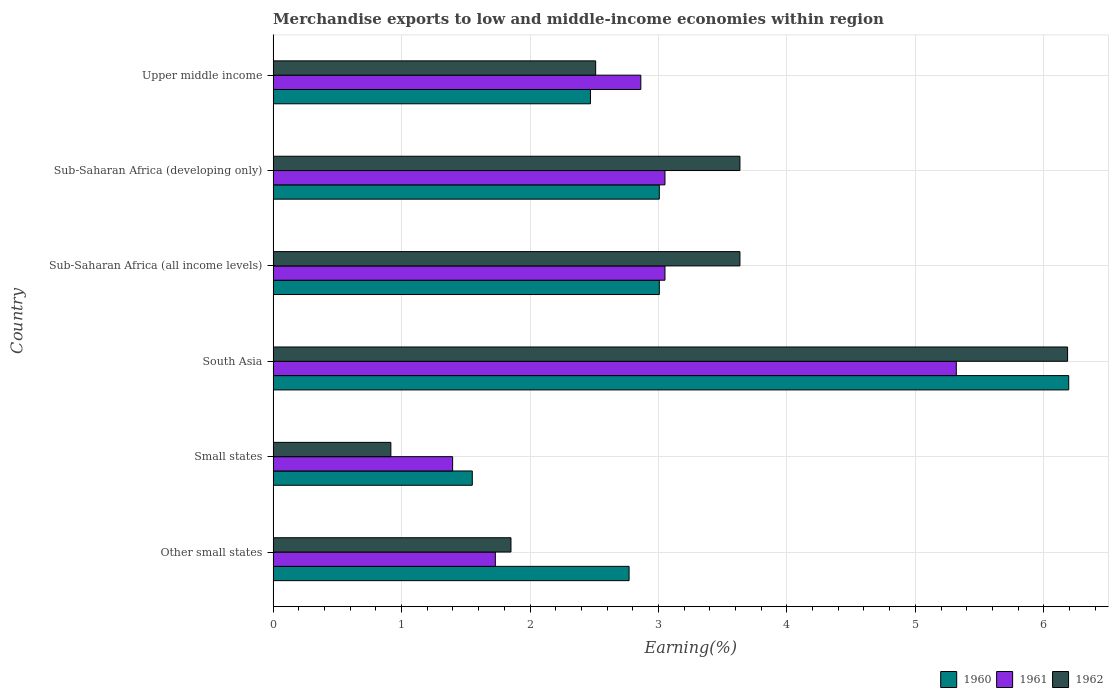Are the number of bars on each tick of the Y-axis equal?
Your answer should be very brief. Yes. What is the label of the 5th group of bars from the top?
Keep it short and to the point. Small states. In how many cases, is the number of bars for a given country not equal to the number of legend labels?
Offer a terse response. 0. What is the percentage of amount earned from merchandise exports in 1961 in Sub-Saharan Africa (all income levels)?
Your response must be concise. 3.05. Across all countries, what is the maximum percentage of amount earned from merchandise exports in 1962?
Provide a short and direct response. 6.19. Across all countries, what is the minimum percentage of amount earned from merchandise exports in 1960?
Make the answer very short. 1.55. In which country was the percentage of amount earned from merchandise exports in 1960 maximum?
Give a very brief answer. South Asia. In which country was the percentage of amount earned from merchandise exports in 1960 minimum?
Your response must be concise. Small states. What is the total percentage of amount earned from merchandise exports in 1960 in the graph?
Make the answer very short. 19. What is the difference between the percentage of amount earned from merchandise exports in 1960 in Small states and that in Sub-Saharan Africa (all income levels)?
Your response must be concise. -1.46. What is the difference between the percentage of amount earned from merchandise exports in 1962 in Upper middle income and the percentage of amount earned from merchandise exports in 1960 in Other small states?
Offer a terse response. -0.26. What is the average percentage of amount earned from merchandise exports in 1961 per country?
Your answer should be compact. 2.9. What is the difference between the percentage of amount earned from merchandise exports in 1962 and percentage of amount earned from merchandise exports in 1960 in South Asia?
Provide a succinct answer. -0.01. In how many countries, is the percentage of amount earned from merchandise exports in 1961 greater than 3 %?
Your answer should be compact. 3. What is the ratio of the percentage of amount earned from merchandise exports in 1960 in South Asia to that in Sub-Saharan Africa (all income levels)?
Provide a succinct answer. 2.06. Is the percentage of amount earned from merchandise exports in 1961 in Small states less than that in Sub-Saharan Africa (all income levels)?
Your answer should be very brief. Yes. Is the difference between the percentage of amount earned from merchandise exports in 1962 in Other small states and South Asia greater than the difference between the percentage of amount earned from merchandise exports in 1960 in Other small states and South Asia?
Your answer should be compact. No. What is the difference between the highest and the second highest percentage of amount earned from merchandise exports in 1961?
Provide a short and direct response. 2.27. What is the difference between the highest and the lowest percentage of amount earned from merchandise exports in 1962?
Your answer should be compact. 5.27. Is the sum of the percentage of amount earned from merchandise exports in 1960 in South Asia and Upper middle income greater than the maximum percentage of amount earned from merchandise exports in 1961 across all countries?
Keep it short and to the point. Yes. Is it the case that in every country, the sum of the percentage of amount earned from merchandise exports in 1962 and percentage of amount earned from merchandise exports in 1961 is greater than the percentage of amount earned from merchandise exports in 1960?
Provide a succinct answer. Yes. How many bars are there?
Your response must be concise. 18. Are the values on the major ticks of X-axis written in scientific E-notation?
Give a very brief answer. No. Does the graph contain any zero values?
Offer a terse response. No. Where does the legend appear in the graph?
Provide a succinct answer. Bottom right. How are the legend labels stacked?
Your answer should be compact. Horizontal. What is the title of the graph?
Provide a short and direct response. Merchandise exports to low and middle-income economies within region. Does "2013" appear as one of the legend labels in the graph?
Offer a very short reply. No. What is the label or title of the X-axis?
Ensure brevity in your answer.  Earning(%). What is the label or title of the Y-axis?
Ensure brevity in your answer.  Country. What is the Earning(%) in 1960 in Other small states?
Make the answer very short. 2.77. What is the Earning(%) of 1961 in Other small states?
Your answer should be compact. 1.73. What is the Earning(%) of 1962 in Other small states?
Offer a terse response. 1.85. What is the Earning(%) of 1960 in Small states?
Your response must be concise. 1.55. What is the Earning(%) of 1961 in Small states?
Your answer should be very brief. 1.4. What is the Earning(%) of 1962 in Small states?
Offer a very short reply. 0.92. What is the Earning(%) of 1960 in South Asia?
Ensure brevity in your answer.  6.19. What is the Earning(%) of 1961 in South Asia?
Provide a short and direct response. 5.32. What is the Earning(%) in 1962 in South Asia?
Provide a succinct answer. 6.19. What is the Earning(%) in 1960 in Sub-Saharan Africa (all income levels)?
Your answer should be very brief. 3.01. What is the Earning(%) of 1961 in Sub-Saharan Africa (all income levels)?
Your response must be concise. 3.05. What is the Earning(%) of 1962 in Sub-Saharan Africa (all income levels)?
Your answer should be compact. 3.63. What is the Earning(%) of 1960 in Sub-Saharan Africa (developing only)?
Keep it short and to the point. 3.01. What is the Earning(%) in 1961 in Sub-Saharan Africa (developing only)?
Offer a very short reply. 3.05. What is the Earning(%) in 1962 in Sub-Saharan Africa (developing only)?
Your answer should be very brief. 3.63. What is the Earning(%) of 1960 in Upper middle income?
Your answer should be very brief. 2.47. What is the Earning(%) of 1961 in Upper middle income?
Make the answer very short. 2.86. What is the Earning(%) of 1962 in Upper middle income?
Offer a very short reply. 2.51. Across all countries, what is the maximum Earning(%) in 1960?
Offer a terse response. 6.19. Across all countries, what is the maximum Earning(%) in 1961?
Ensure brevity in your answer.  5.32. Across all countries, what is the maximum Earning(%) in 1962?
Make the answer very short. 6.19. Across all countries, what is the minimum Earning(%) in 1960?
Make the answer very short. 1.55. Across all countries, what is the minimum Earning(%) in 1961?
Give a very brief answer. 1.4. Across all countries, what is the minimum Earning(%) in 1962?
Provide a short and direct response. 0.92. What is the total Earning(%) of 1960 in the graph?
Provide a short and direct response. 19. What is the total Earning(%) in 1961 in the graph?
Ensure brevity in your answer.  17.41. What is the total Earning(%) in 1962 in the graph?
Your answer should be compact. 18.73. What is the difference between the Earning(%) of 1960 in Other small states and that in Small states?
Offer a terse response. 1.22. What is the difference between the Earning(%) of 1961 in Other small states and that in Small states?
Your response must be concise. 0.33. What is the difference between the Earning(%) in 1962 in Other small states and that in Small states?
Ensure brevity in your answer.  0.94. What is the difference between the Earning(%) in 1960 in Other small states and that in South Asia?
Offer a terse response. -3.42. What is the difference between the Earning(%) of 1961 in Other small states and that in South Asia?
Offer a terse response. -3.59. What is the difference between the Earning(%) of 1962 in Other small states and that in South Asia?
Your response must be concise. -4.33. What is the difference between the Earning(%) of 1960 in Other small states and that in Sub-Saharan Africa (all income levels)?
Ensure brevity in your answer.  -0.24. What is the difference between the Earning(%) of 1961 in Other small states and that in Sub-Saharan Africa (all income levels)?
Offer a terse response. -1.32. What is the difference between the Earning(%) of 1962 in Other small states and that in Sub-Saharan Africa (all income levels)?
Your response must be concise. -1.78. What is the difference between the Earning(%) of 1960 in Other small states and that in Sub-Saharan Africa (developing only)?
Your answer should be very brief. -0.24. What is the difference between the Earning(%) of 1961 in Other small states and that in Sub-Saharan Africa (developing only)?
Make the answer very short. -1.32. What is the difference between the Earning(%) of 1962 in Other small states and that in Sub-Saharan Africa (developing only)?
Provide a short and direct response. -1.78. What is the difference between the Earning(%) of 1960 in Other small states and that in Upper middle income?
Give a very brief answer. 0.3. What is the difference between the Earning(%) in 1961 in Other small states and that in Upper middle income?
Offer a terse response. -1.13. What is the difference between the Earning(%) of 1962 in Other small states and that in Upper middle income?
Your answer should be compact. -0.66. What is the difference between the Earning(%) of 1960 in Small states and that in South Asia?
Provide a short and direct response. -4.64. What is the difference between the Earning(%) of 1961 in Small states and that in South Asia?
Provide a succinct answer. -3.92. What is the difference between the Earning(%) of 1962 in Small states and that in South Asia?
Make the answer very short. -5.27. What is the difference between the Earning(%) in 1960 in Small states and that in Sub-Saharan Africa (all income levels)?
Offer a terse response. -1.46. What is the difference between the Earning(%) in 1961 in Small states and that in Sub-Saharan Africa (all income levels)?
Your answer should be compact. -1.65. What is the difference between the Earning(%) of 1962 in Small states and that in Sub-Saharan Africa (all income levels)?
Your answer should be compact. -2.72. What is the difference between the Earning(%) of 1960 in Small states and that in Sub-Saharan Africa (developing only)?
Give a very brief answer. -1.46. What is the difference between the Earning(%) in 1961 in Small states and that in Sub-Saharan Africa (developing only)?
Your answer should be compact. -1.65. What is the difference between the Earning(%) of 1962 in Small states and that in Sub-Saharan Africa (developing only)?
Make the answer very short. -2.72. What is the difference between the Earning(%) of 1960 in Small states and that in Upper middle income?
Your response must be concise. -0.92. What is the difference between the Earning(%) of 1961 in Small states and that in Upper middle income?
Provide a succinct answer. -1.47. What is the difference between the Earning(%) in 1962 in Small states and that in Upper middle income?
Make the answer very short. -1.59. What is the difference between the Earning(%) of 1960 in South Asia and that in Sub-Saharan Africa (all income levels)?
Keep it short and to the point. 3.19. What is the difference between the Earning(%) in 1961 in South Asia and that in Sub-Saharan Africa (all income levels)?
Offer a very short reply. 2.27. What is the difference between the Earning(%) of 1962 in South Asia and that in Sub-Saharan Africa (all income levels)?
Provide a succinct answer. 2.55. What is the difference between the Earning(%) in 1960 in South Asia and that in Sub-Saharan Africa (developing only)?
Your answer should be compact. 3.19. What is the difference between the Earning(%) in 1961 in South Asia and that in Sub-Saharan Africa (developing only)?
Provide a succinct answer. 2.27. What is the difference between the Earning(%) in 1962 in South Asia and that in Sub-Saharan Africa (developing only)?
Keep it short and to the point. 2.55. What is the difference between the Earning(%) of 1960 in South Asia and that in Upper middle income?
Offer a terse response. 3.72. What is the difference between the Earning(%) in 1961 in South Asia and that in Upper middle income?
Your answer should be very brief. 2.46. What is the difference between the Earning(%) of 1962 in South Asia and that in Upper middle income?
Give a very brief answer. 3.67. What is the difference between the Earning(%) of 1960 in Sub-Saharan Africa (all income levels) and that in Sub-Saharan Africa (developing only)?
Give a very brief answer. 0. What is the difference between the Earning(%) in 1961 in Sub-Saharan Africa (all income levels) and that in Sub-Saharan Africa (developing only)?
Offer a terse response. 0. What is the difference between the Earning(%) in 1962 in Sub-Saharan Africa (all income levels) and that in Sub-Saharan Africa (developing only)?
Make the answer very short. 0. What is the difference between the Earning(%) in 1960 in Sub-Saharan Africa (all income levels) and that in Upper middle income?
Your answer should be very brief. 0.54. What is the difference between the Earning(%) of 1961 in Sub-Saharan Africa (all income levels) and that in Upper middle income?
Provide a succinct answer. 0.19. What is the difference between the Earning(%) of 1962 in Sub-Saharan Africa (all income levels) and that in Upper middle income?
Give a very brief answer. 1.12. What is the difference between the Earning(%) in 1960 in Sub-Saharan Africa (developing only) and that in Upper middle income?
Make the answer very short. 0.54. What is the difference between the Earning(%) in 1961 in Sub-Saharan Africa (developing only) and that in Upper middle income?
Make the answer very short. 0.19. What is the difference between the Earning(%) in 1962 in Sub-Saharan Africa (developing only) and that in Upper middle income?
Provide a succinct answer. 1.12. What is the difference between the Earning(%) in 1960 in Other small states and the Earning(%) in 1961 in Small states?
Offer a terse response. 1.37. What is the difference between the Earning(%) in 1960 in Other small states and the Earning(%) in 1962 in Small states?
Give a very brief answer. 1.85. What is the difference between the Earning(%) in 1961 in Other small states and the Earning(%) in 1962 in Small states?
Offer a very short reply. 0.81. What is the difference between the Earning(%) of 1960 in Other small states and the Earning(%) of 1961 in South Asia?
Your answer should be very brief. -2.55. What is the difference between the Earning(%) in 1960 in Other small states and the Earning(%) in 1962 in South Asia?
Make the answer very short. -3.41. What is the difference between the Earning(%) in 1961 in Other small states and the Earning(%) in 1962 in South Asia?
Provide a short and direct response. -4.46. What is the difference between the Earning(%) in 1960 in Other small states and the Earning(%) in 1961 in Sub-Saharan Africa (all income levels)?
Keep it short and to the point. -0.28. What is the difference between the Earning(%) in 1960 in Other small states and the Earning(%) in 1962 in Sub-Saharan Africa (all income levels)?
Your answer should be very brief. -0.86. What is the difference between the Earning(%) in 1961 in Other small states and the Earning(%) in 1962 in Sub-Saharan Africa (all income levels)?
Give a very brief answer. -1.9. What is the difference between the Earning(%) in 1960 in Other small states and the Earning(%) in 1961 in Sub-Saharan Africa (developing only)?
Your answer should be compact. -0.28. What is the difference between the Earning(%) in 1960 in Other small states and the Earning(%) in 1962 in Sub-Saharan Africa (developing only)?
Provide a short and direct response. -0.86. What is the difference between the Earning(%) in 1961 in Other small states and the Earning(%) in 1962 in Sub-Saharan Africa (developing only)?
Your response must be concise. -1.9. What is the difference between the Earning(%) of 1960 in Other small states and the Earning(%) of 1961 in Upper middle income?
Provide a short and direct response. -0.09. What is the difference between the Earning(%) of 1960 in Other small states and the Earning(%) of 1962 in Upper middle income?
Your answer should be very brief. 0.26. What is the difference between the Earning(%) in 1961 in Other small states and the Earning(%) in 1962 in Upper middle income?
Offer a terse response. -0.78. What is the difference between the Earning(%) in 1960 in Small states and the Earning(%) in 1961 in South Asia?
Offer a very short reply. -3.77. What is the difference between the Earning(%) in 1960 in Small states and the Earning(%) in 1962 in South Asia?
Provide a short and direct response. -4.63. What is the difference between the Earning(%) of 1961 in Small states and the Earning(%) of 1962 in South Asia?
Keep it short and to the point. -4.79. What is the difference between the Earning(%) in 1960 in Small states and the Earning(%) in 1961 in Sub-Saharan Africa (all income levels)?
Your response must be concise. -1.5. What is the difference between the Earning(%) of 1960 in Small states and the Earning(%) of 1962 in Sub-Saharan Africa (all income levels)?
Ensure brevity in your answer.  -2.08. What is the difference between the Earning(%) in 1961 in Small states and the Earning(%) in 1962 in Sub-Saharan Africa (all income levels)?
Provide a short and direct response. -2.24. What is the difference between the Earning(%) in 1960 in Small states and the Earning(%) in 1961 in Sub-Saharan Africa (developing only)?
Make the answer very short. -1.5. What is the difference between the Earning(%) in 1960 in Small states and the Earning(%) in 1962 in Sub-Saharan Africa (developing only)?
Your answer should be very brief. -2.08. What is the difference between the Earning(%) in 1961 in Small states and the Earning(%) in 1962 in Sub-Saharan Africa (developing only)?
Keep it short and to the point. -2.24. What is the difference between the Earning(%) of 1960 in Small states and the Earning(%) of 1961 in Upper middle income?
Your response must be concise. -1.31. What is the difference between the Earning(%) of 1960 in Small states and the Earning(%) of 1962 in Upper middle income?
Ensure brevity in your answer.  -0.96. What is the difference between the Earning(%) of 1961 in Small states and the Earning(%) of 1962 in Upper middle income?
Provide a succinct answer. -1.11. What is the difference between the Earning(%) in 1960 in South Asia and the Earning(%) in 1961 in Sub-Saharan Africa (all income levels)?
Make the answer very short. 3.14. What is the difference between the Earning(%) of 1960 in South Asia and the Earning(%) of 1962 in Sub-Saharan Africa (all income levels)?
Give a very brief answer. 2.56. What is the difference between the Earning(%) in 1961 in South Asia and the Earning(%) in 1962 in Sub-Saharan Africa (all income levels)?
Give a very brief answer. 1.68. What is the difference between the Earning(%) of 1960 in South Asia and the Earning(%) of 1961 in Sub-Saharan Africa (developing only)?
Offer a terse response. 3.14. What is the difference between the Earning(%) of 1960 in South Asia and the Earning(%) of 1962 in Sub-Saharan Africa (developing only)?
Provide a succinct answer. 2.56. What is the difference between the Earning(%) in 1961 in South Asia and the Earning(%) in 1962 in Sub-Saharan Africa (developing only)?
Ensure brevity in your answer.  1.68. What is the difference between the Earning(%) of 1960 in South Asia and the Earning(%) of 1961 in Upper middle income?
Keep it short and to the point. 3.33. What is the difference between the Earning(%) of 1960 in South Asia and the Earning(%) of 1962 in Upper middle income?
Make the answer very short. 3.68. What is the difference between the Earning(%) in 1961 in South Asia and the Earning(%) in 1962 in Upper middle income?
Offer a very short reply. 2.81. What is the difference between the Earning(%) of 1960 in Sub-Saharan Africa (all income levels) and the Earning(%) of 1961 in Sub-Saharan Africa (developing only)?
Your response must be concise. -0.04. What is the difference between the Earning(%) of 1960 in Sub-Saharan Africa (all income levels) and the Earning(%) of 1962 in Sub-Saharan Africa (developing only)?
Give a very brief answer. -0.63. What is the difference between the Earning(%) in 1961 in Sub-Saharan Africa (all income levels) and the Earning(%) in 1962 in Sub-Saharan Africa (developing only)?
Your response must be concise. -0.58. What is the difference between the Earning(%) of 1960 in Sub-Saharan Africa (all income levels) and the Earning(%) of 1961 in Upper middle income?
Your answer should be compact. 0.14. What is the difference between the Earning(%) in 1960 in Sub-Saharan Africa (all income levels) and the Earning(%) in 1962 in Upper middle income?
Provide a short and direct response. 0.5. What is the difference between the Earning(%) of 1961 in Sub-Saharan Africa (all income levels) and the Earning(%) of 1962 in Upper middle income?
Offer a terse response. 0.54. What is the difference between the Earning(%) of 1960 in Sub-Saharan Africa (developing only) and the Earning(%) of 1961 in Upper middle income?
Provide a short and direct response. 0.14. What is the difference between the Earning(%) of 1960 in Sub-Saharan Africa (developing only) and the Earning(%) of 1962 in Upper middle income?
Offer a very short reply. 0.5. What is the difference between the Earning(%) of 1961 in Sub-Saharan Africa (developing only) and the Earning(%) of 1962 in Upper middle income?
Give a very brief answer. 0.54. What is the average Earning(%) of 1960 per country?
Your answer should be compact. 3.17. What is the average Earning(%) in 1961 per country?
Offer a terse response. 2.9. What is the average Earning(%) of 1962 per country?
Ensure brevity in your answer.  3.12. What is the difference between the Earning(%) of 1960 and Earning(%) of 1961 in Other small states?
Give a very brief answer. 1.04. What is the difference between the Earning(%) of 1960 and Earning(%) of 1962 in Other small states?
Your answer should be very brief. 0.92. What is the difference between the Earning(%) in 1961 and Earning(%) in 1962 in Other small states?
Ensure brevity in your answer.  -0.12. What is the difference between the Earning(%) of 1960 and Earning(%) of 1961 in Small states?
Provide a succinct answer. 0.15. What is the difference between the Earning(%) in 1960 and Earning(%) in 1962 in Small states?
Ensure brevity in your answer.  0.63. What is the difference between the Earning(%) in 1961 and Earning(%) in 1962 in Small states?
Provide a succinct answer. 0.48. What is the difference between the Earning(%) in 1960 and Earning(%) in 1961 in South Asia?
Your answer should be very brief. 0.88. What is the difference between the Earning(%) of 1960 and Earning(%) of 1962 in South Asia?
Ensure brevity in your answer.  0.01. What is the difference between the Earning(%) in 1961 and Earning(%) in 1962 in South Asia?
Ensure brevity in your answer.  -0.87. What is the difference between the Earning(%) in 1960 and Earning(%) in 1961 in Sub-Saharan Africa (all income levels)?
Provide a succinct answer. -0.04. What is the difference between the Earning(%) in 1960 and Earning(%) in 1962 in Sub-Saharan Africa (all income levels)?
Offer a terse response. -0.63. What is the difference between the Earning(%) of 1961 and Earning(%) of 1962 in Sub-Saharan Africa (all income levels)?
Make the answer very short. -0.58. What is the difference between the Earning(%) of 1960 and Earning(%) of 1961 in Sub-Saharan Africa (developing only)?
Ensure brevity in your answer.  -0.04. What is the difference between the Earning(%) of 1960 and Earning(%) of 1962 in Sub-Saharan Africa (developing only)?
Offer a terse response. -0.63. What is the difference between the Earning(%) of 1961 and Earning(%) of 1962 in Sub-Saharan Africa (developing only)?
Your answer should be compact. -0.58. What is the difference between the Earning(%) in 1960 and Earning(%) in 1961 in Upper middle income?
Offer a terse response. -0.39. What is the difference between the Earning(%) of 1960 and Earning(%) of 1962 in Upper middle income?
Give a very brief answer. -0.04. What is the difference between the Earning(%) in 1961 and Earning(%) in 1962 in Upper middle income?
Your answer should be compact. 0.35. What is the ratio of the Earning(%) in 1960 in Other small states to that in Small states?
Give a very brief answer. 1.79. What is the ratio of the Earning(%) of 1961 in Other small states to that in Small states?
Give a very brief answer. 1.24. What is the ratio of the Earning(%) of 1962 in Other small states to that in Small states?
Your answer should be very brief. 2.02. What is the ratio of the Earning(%) of 1960 in Other small states to that in South Asia?
Keep it short and to the point. 0.45. What is the ratio of the Earning(%) of 1961 in Other small states to that in South Asia?
Offer a very short reply. 0.33. What is the ratio of the Earning(%) of 1962 in Other small states to that in South Asia?
Your answer should be very brief. 0.3. What is the ratio of the Earning(%) of 1960 in Other small states to that in Sub-Saharan Africa (all income levels)?
Make the answer very short. 0.92. What is the ratio of the Earning(%) of 1961 in Other small states to that in Sub-Saharan Africa (all income levels)?
Your answer should be very brief. 0.57. What is the ratio of the Earning(%) in 1962 in Other small states to that in Sub-Saharan Africa (all income levels)?
Your answer should be very brief. 0.51. What is the ratio of the Earning(%) in 1960 in Other small states to that in Sub-Saharan Africa (developing only)?
Offer a terse response. 0.92. What is the ratio of the Earning(%) in 1961 in Other small states to that in Sub-Saharan Africa (developing only)?
Keep it short and to the point. 0.57. What is the ratio of the Earning(%) of 1962 in Other small states to that in Sub-Saharan Africa (developing only)?
Offer a very short reply. 0.51. What is the ratio of the Earning(%) of 1960 in Other small states to that in Upper middle income?
Your answer should be compact. 1.12. What is the ratio of the Earning(%) in 1961 in Other small states to that in Upper middle income?
Your response must be concise. 0.6. What is the ratio of the Earning(%) in 1962 in Other small states to that in Upper middle income?
Offer a very short reply. 0.74. What is the ratio of the Earning(%) of 1960 in Small states to that in South Asia?
Offer a terse response. 0.25. What is the ratio of the Earning(%) in 1961 in Small states to that in South Asia?
Your answer should be very brief. 0.26. What is the ratio of the Earning(%) of 1962 in Small states to that in South Asia?
Keep it short and to the point. 0.15. What is the ratio of the Earning(%) of 1960 in Small states to that in Sub-Saharan Africa (all income levels)?
Ensure brevity in your answer.  0.52. What is the ratio of the Earning(%) in 1961 in Small states to that in Sub-Saharan Africa (all income levels)?
Your answer should be very brief. 0.46. What is the ratio of the Earning(%) in 1962 in Small states to that in Sub-Saharan Africa (all income levels)?
Make the answer very short. 0.25. What is the ratio of the Earning(%) in 1960 in Small states to that in Sub-Saharan Africa (developing only)?
Your answer should be compact. 0.52. What is the ratio of the Earning(%) of 1961 in Small states to that in Sub-Saharan Africa (developing only)?
Provide a succinct answer. 0.46. What is the ratio of the Earning(%) of 1962 in Small states to that in Sub-Saharan Africa (developing only)?
Provide a succinct answer. 0.25. What is the ratio of the Earning(%) in 1960 in Small states to that in Upper middle income?
Ensure brevity in your answer.  0.63. What is the ratio of the Earning(%) in 1961 in Small states to that in Upper middle income?
Give a very brief answer. 0.49. What is the ratio of the Earning(%) of 1962 in Small states to that in Upper middle income?
Your answer should be compact. 0.36. What is the ratio of the Earning(%) in 1960 in South Asia to that in Sub-Saharan Africa (all income levels)?
Offer a very short reply. 2.06. What is the ratio of the Earning(%) of 1961 in South Asia to that in Sub-Saharan Africa (all income levels)?
Provide a succinct answer. 1.74. What is the ratio of the Earning(%) in 1962 in South Asia to that in Sub-Saharan Africa (all income levels)?
Keep it short and to the point. 1.7. What is the ratio of the Earning(%) in 1960 in South Asia to that in Sub-Saharan Africa (developing only)?
Your response must be concise. 2.06. What is the ratio of the Earning(%) of 1961 in South Asia to that in Sub-Saharan Africa (developing only)?
Make the answer very short. 1.74. What is the ratio of the Earning(%) in 1962 in South Asia to that in Sub-Saharan Africa (developing only)?
Keep it short and to the point. 1.7. What is the ratio of the Earning(%) in 1960 in South Asia to that in Upper middle income?
Ensure brevity in your answer.  2.51. What is the ratio of the Earning(%) in 1961 in South Asia to that in Upper middle income?
Provide a short and direct response. 1.86. What is the ratio of the Earning(%) in 1962 in South Asia to that in Upper middle income?
Your response must be concise. 2.46. What is the ratio of the Earning(%) in 1960 in Sub-Saharan Africa (all income levels) to that in Upper middle income?
Your answer should be compact. 1.22. What is the ratio of the Earning(%) in 1961 in Sub-Saharan Africa (all income levels) to that in Upper middle income?
Give a very brief answer. 1.07. What is the ratio of the Earning(%) of 1962 in Sub-Saharan Africa (all income levels) to that in Upper middle income?
Provide a short and direct response. 1.45. What is the ratio of the Earning(%) of 1960 in Sub-Saharan Africa (developing only) to that in Upper middle income?
Your response must be concise. 1.22. What is the ratio of the Earning(%) of 1961 in Sub-Saharan Africa (developing only) to that in Upper middle income?
Provide a succinct answer. 1.07. What is the ratio of the Earning(%) in 1962 in Sub-Saharan Africa (developing only) to that in Upper middle income?
Offer a very short reply. 1.45. What is the difference between the highest and the second highest Earning(%) of 1960?
Provide a short and direct response. 3.19. What is the difference between the highest and the second highest Earning(%) in 1961?
Your answer should be compact. 2.27. What is the difference between the highest and the second highest Earning(%) of 1962?
Your response must be concise. 2.55. What is the difference between the highest and the lowest Earning(%) of 1960?
Ensure brevity in your answer.  4.64. What is the difference between the highest and the lowest Earning(%) in 1961?
Offer a terse response. 3.92. What is the difference between the highest and the lowest Earning(%) in 1962?
Provide a short and direct response. 5.27. 